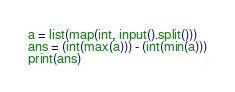Convert code to text. <code><loc_0><loc_0><loc_500><loc_500><_Python_>a = list(map(int, input().split()))
ans = (int(max(a))) - (int(min(a)))
print(ans)
</code> 